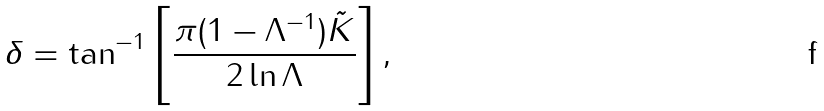<formula> <loc_0><loc_0><loc_500><loc_500>\delta = \tan ^ { - 1 } \left [ \frac { \pi ( 1 - \Lambda ^ { - 1 } ) \tilde { K } } { 2 \ln \Lambda } \right ] ,</formula> 